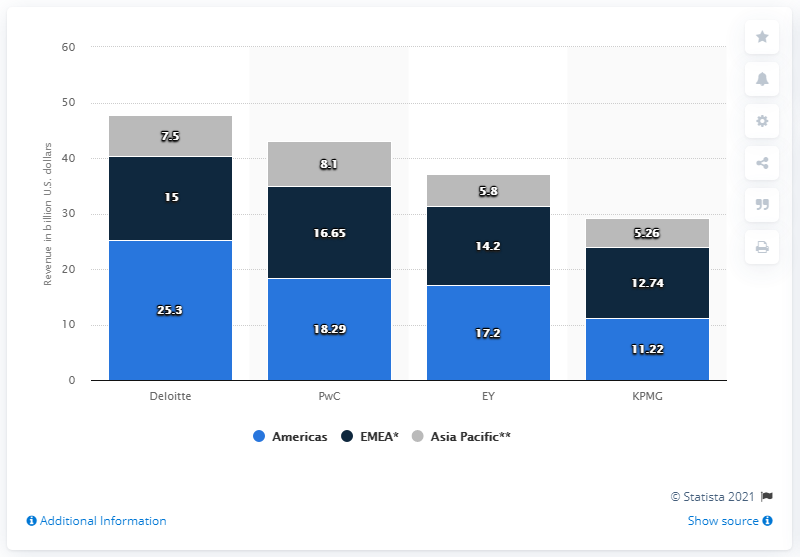Point out several critical features in this image. PwC emerged as the winner in both the Asia Pacific and EMEA (Europe, Middle East, and Africa) regions. 